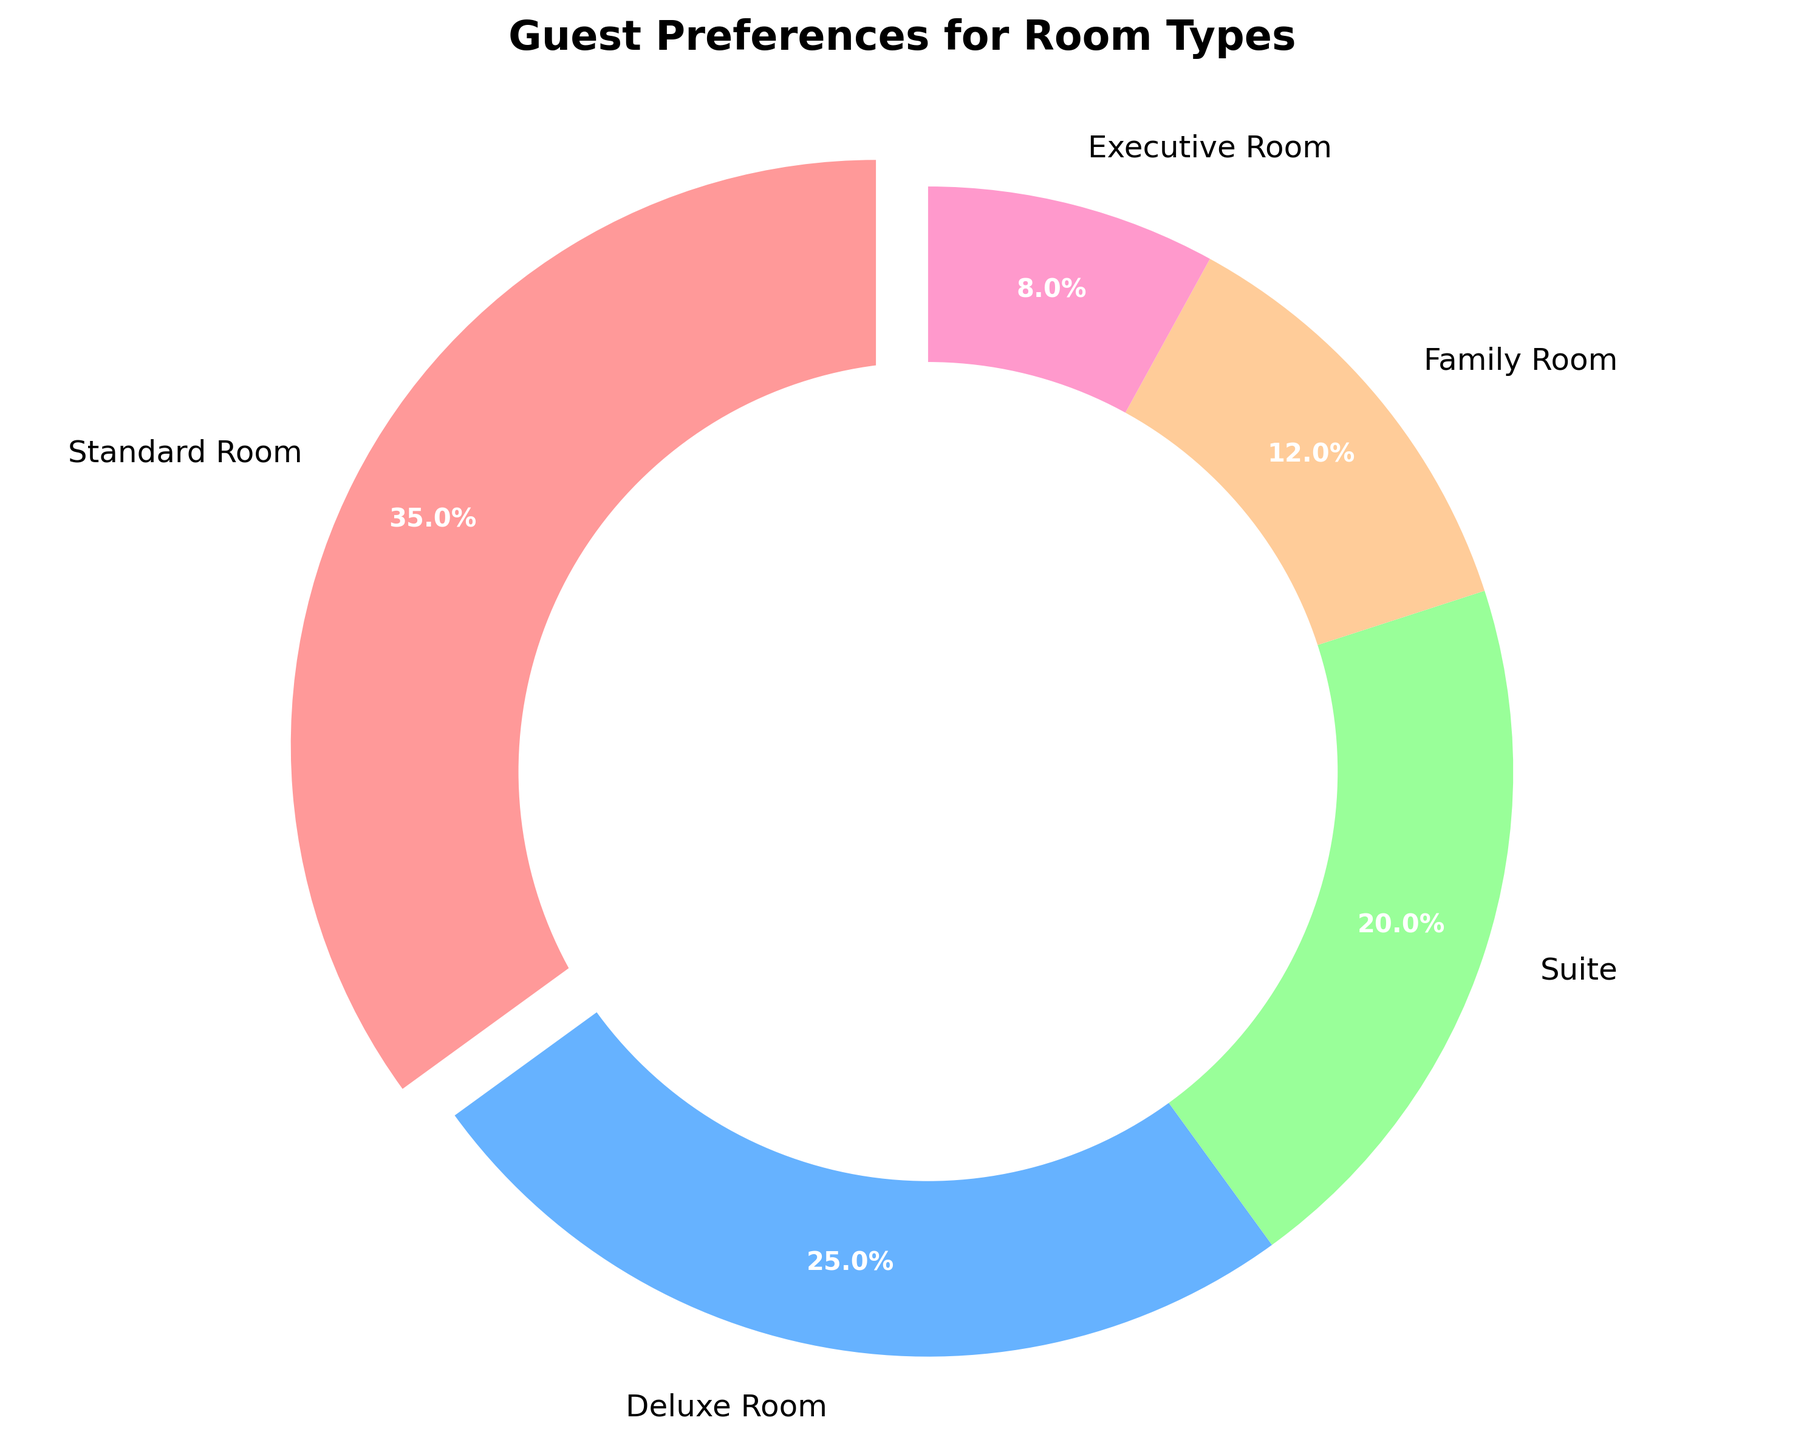Which room type has the highest preference among guests? The figure shows different room types with their corresponding percentages. The room type with the largest percentage is the highest preference.
Answer: Standard Room How many room types have a preference of 20% or more? From the figure, identify the room types with percentages 20% or higher and count them. Standard Room: 35%, Deluxe Room: 25%, Suite: 20%. There are 3 room types.
Answer: 3 Which room type has the lowest preference, and what is its percentage? The figure shows the percentages for each room type. The room with the smallest percentage has the lowest preference. The Executive Room has the lowest percentage of 8%.
Answer: Executive Room, 8% What is the combined preference percentage for Deluxe Room and Suite? Add the percentage values for Deluxe Room and Suite. Deluxe Room: 25%, Suite: 20%. 25% + 20% = 45%.
Answer: 45% How does the percentage preference for Family Room compare to that of Standard Room? Subtract the percentage of Family Room from that of Standard Room. Standard Room: 35%, Family Room: 12%. 35% - 12% = 23%. The Standard Room has a 23% higher preference.
Answer: Standard Room has 23% higher What is the difference in preference percentage between the room type with the highest preference and the room type with the lowest preference? Subtract the percentage of the Executive Room from that of the Standard Room. Standard Room: 35%, Executive Room: 8%. 35% - 8% = 27%.
Answer: 27% If the total number of bookings is 1000, estimate the number of bookings for the Deluxe Room. Multiply the total bookings by the percentage (in decimal form). 1000 * 0.25 = 250 bookings.
Answer: 250 What color represents the Suite on the pie chart? The figure uses specific colors for each room type. The Suites are usually labeled with one distinct color. The pie chart shows Suite in a particular color.
Answer: Green By how much does the preference for Family Room exceed that of Executive Room? Subtract the preference percentage of the Executive Room from the Family Room. Family Room: 12%, Executive Room: 8%. 12% - 8% = 4%.
Answer: 4% Combine the preferences for the Standard Room, Deluxe Room, and Suite to find the total percentage of bookings for these room types. Add the percentage values for the three room types. Standard Room: 35%, Deluxe Room: 25%, Suite: 20%. 35% + 25% + 20% = 80%.
Answer: 80% 